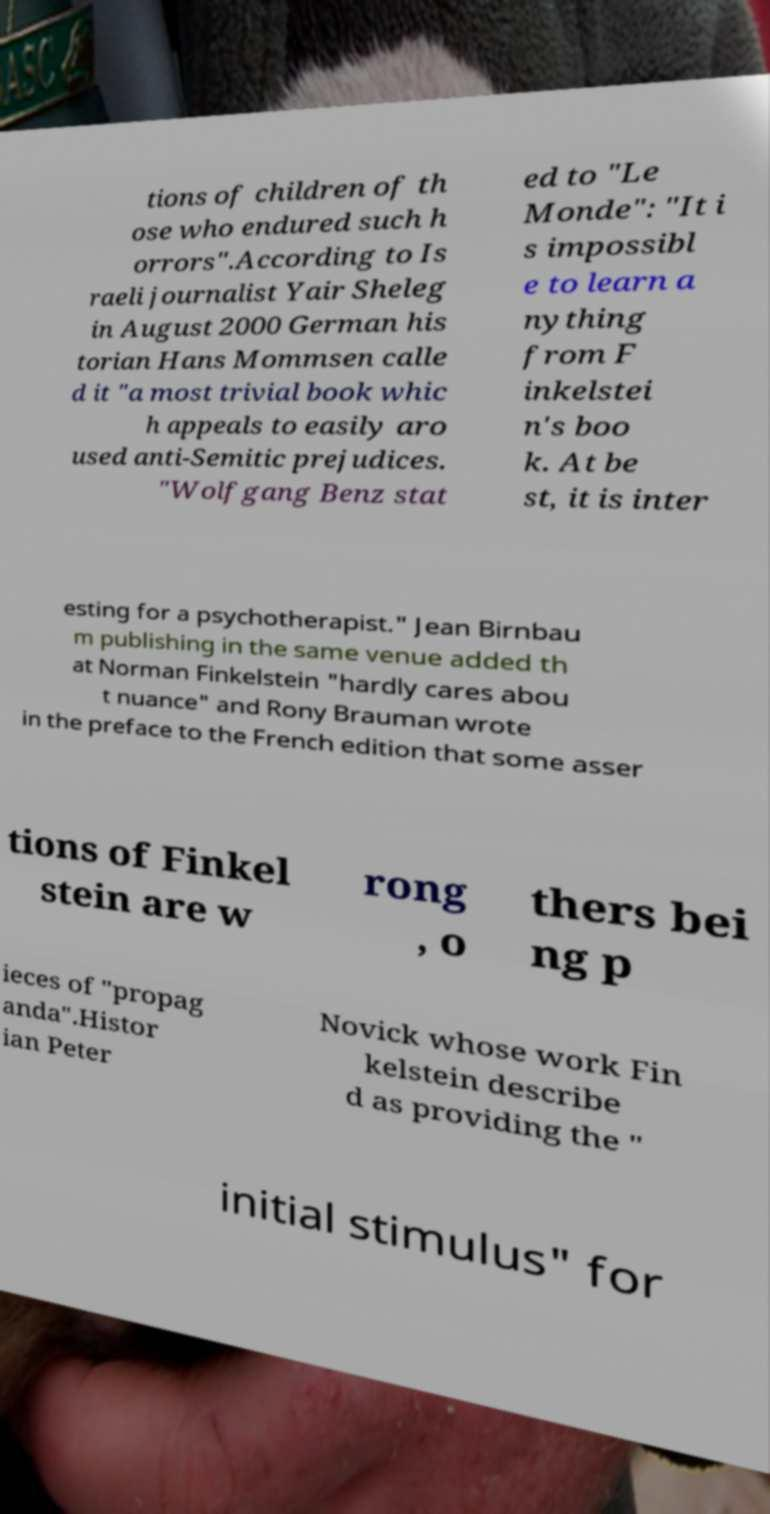Please read and relay the text visible in this image. What does it say? tions of children of th ose who endured such h orrors".According to Is raeli journalist Yair Sheleg in August 2000 German his torian Hans Mommsen calle d it "a most trivial book whic h appeals to easily aro used anti-Semitic prejudices. "Wolfgang Benz stat ed to "Le Monde": "It i s impossibl e to learn a nything from F inkelstei n's boo k. At be st, it is inter esting for a psychotherapist." Jean Birnbau m publishing in the same venue added th at Norman Finkelstein "hardly cares abou t nuance" and Rony Brauman wrote in the preface to the French edition that some asser tions of Finkel stein are w rong , o thers bei ng p ieces of "propag anda".Histor ian Peter Novick whose work Fin kelstein describe d as providing the " initial stimulus" for 